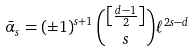Convert formula to latex. <formula><loc_0><loc_0><loc_500><loc_500>\bar { \alpha } _ { s } = \left ( \pm 1 \right ) ^ { s + 1 } \binom { \left [ \frac { d - 1 } { 2 } \right ] } { s } \ell ^ { 2 s - d }</formula> 